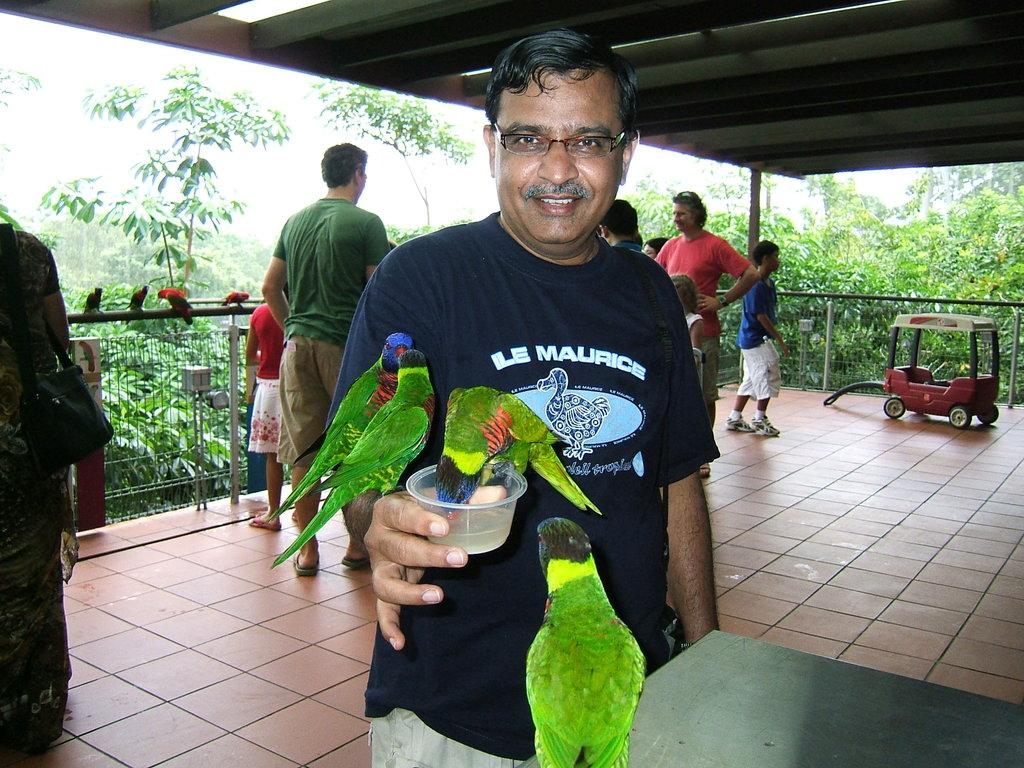Who is present in the image? There is a person in the image. What is the person doing in the image? The person is feeding a bird. What type of beds can be seen in the image? There are no beds present in the image. Can you find a receipt in the image? There is no receipt visible in the image. 